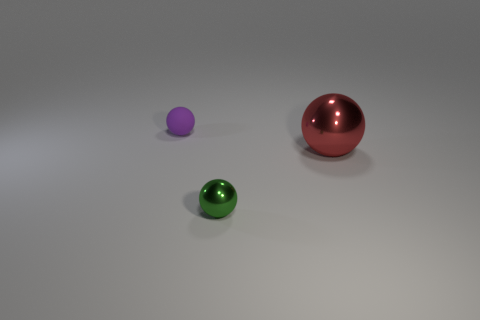Add 1 tiny blocks. How many objects exist? 4 Add 2 green shiny balls. How many green shiny balls exist? 3 Subtract 0 blue cylinders. How many objects are left? 3 Subtract all tiny spheres. Subtract all red objects. How many objects are left? 0 Add 1 tiny purple things. How many tiny purple things are left? 2 